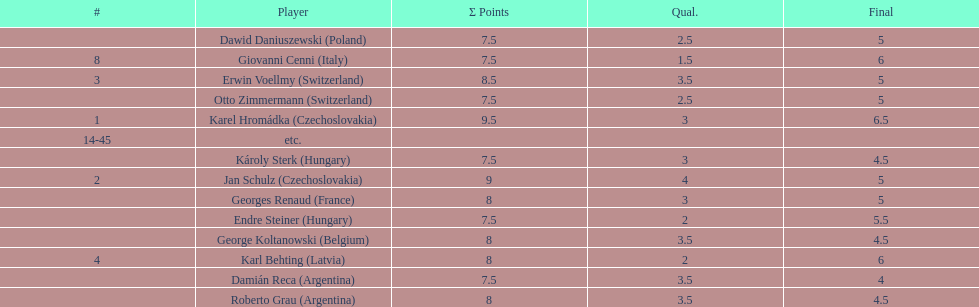Can you parse all the data within this table? {'header': ['#', 'Player', 'Σ Points', 'Qual.', 'Final'], 'rows': [['', 'Dawid Daniuszewski\xa0(Poland)', '7.5', '2.5', '5'], ['8', 'Giovanni Cenni\xa0(Italy)', '7.5', '1.5', '6'], ['3', 'Erwin Voellmy\xa0(Switzerland)', '8.5', '3.5', '5'], ['', 'Otto Zimmermann\xa0(Switzerland)', '7.5', '2.5', '5'], ['1', 'Karel Hromádka\xa0(Czechoslovakia)', '9.5', '3', '6.5'], ['14-45', 'etc.', '', '', ''], ['', 'Károly Sterk\xa0(Hungary)', '7.5', '3', '4.5'], ['2', 'Jan Schulz\xa0(Czechoslovakia)', '9', '4', '5'], ['', 'Georges Renaud\xa0(France)', '8', '3', '5'], ['', 'Endre Steiner\xa0(Hungary)', '7.5', '2', '5.5'], ['', 'George Koltanowski\xa0(Belgium)', '8', '3.5', '4.5'], ['4', 'Karl Behting\xa0(Latvia)', '8', '2', '6'], ['', 'Damián Reca\xa0(Argentina)', '7.5', '3.5', '4'], ['', 'Roberto Grau\xa0(Argentina)', '8', '3.5', '4.5']]} How many players tied for 4th place? 4. 